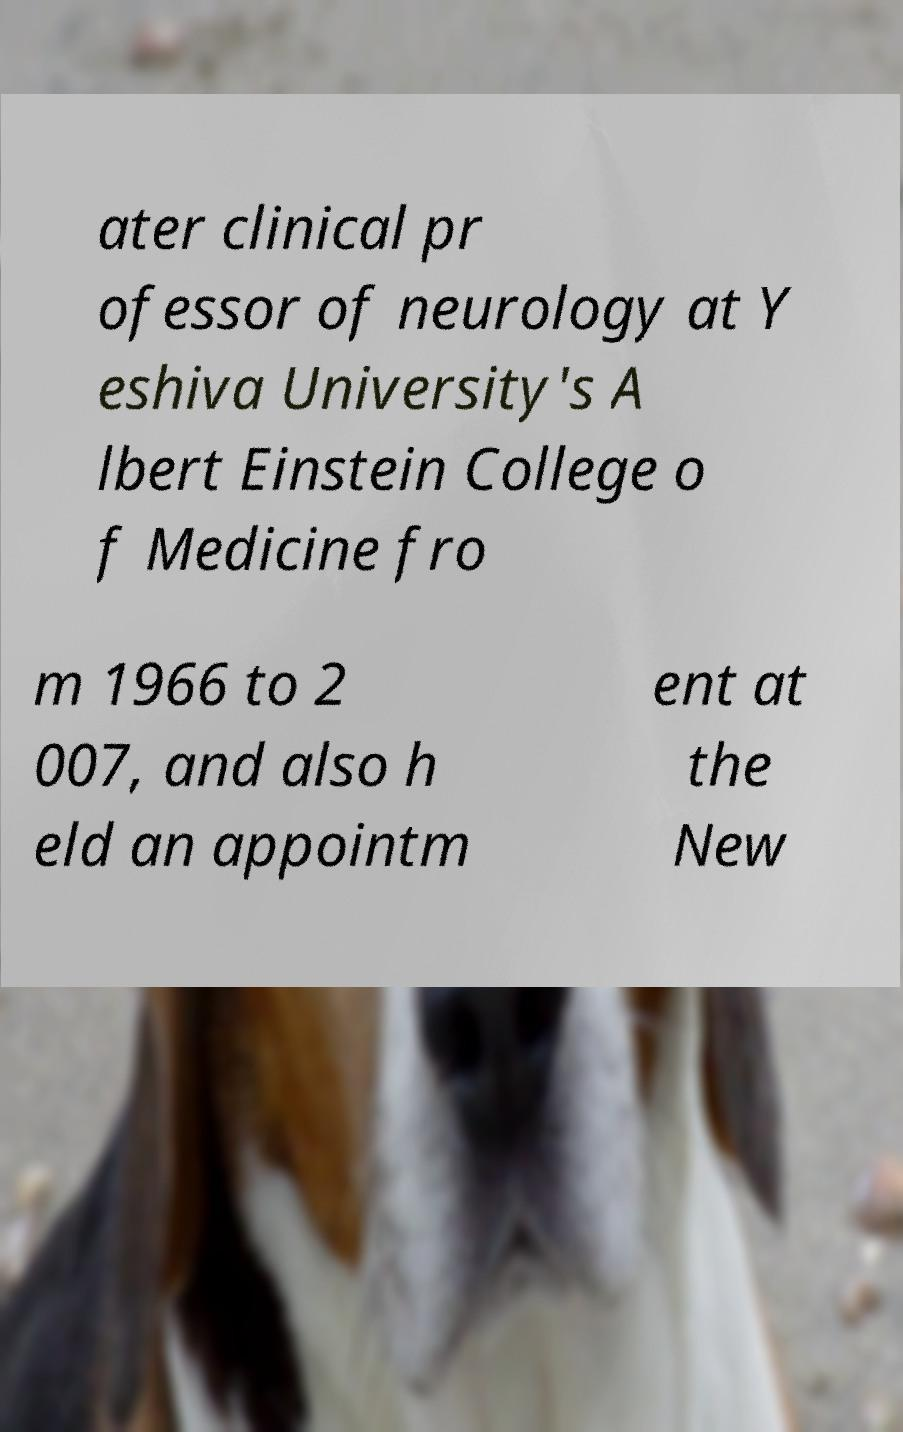Could you extract and type out the text from this image? ater clinical pr ofessor of neurology at Y eshiva University's A lbert Einstein College o f Medicine fro m 1966 to 2 007, and also h eld an appointm ent at the New 